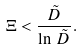Convert formula to latex. <formula><loc_0><loc_0><loc_500><loc_500>\Xi < \frac { \tilde { D } } { \ln \, \tilde { D } } .</formula> 